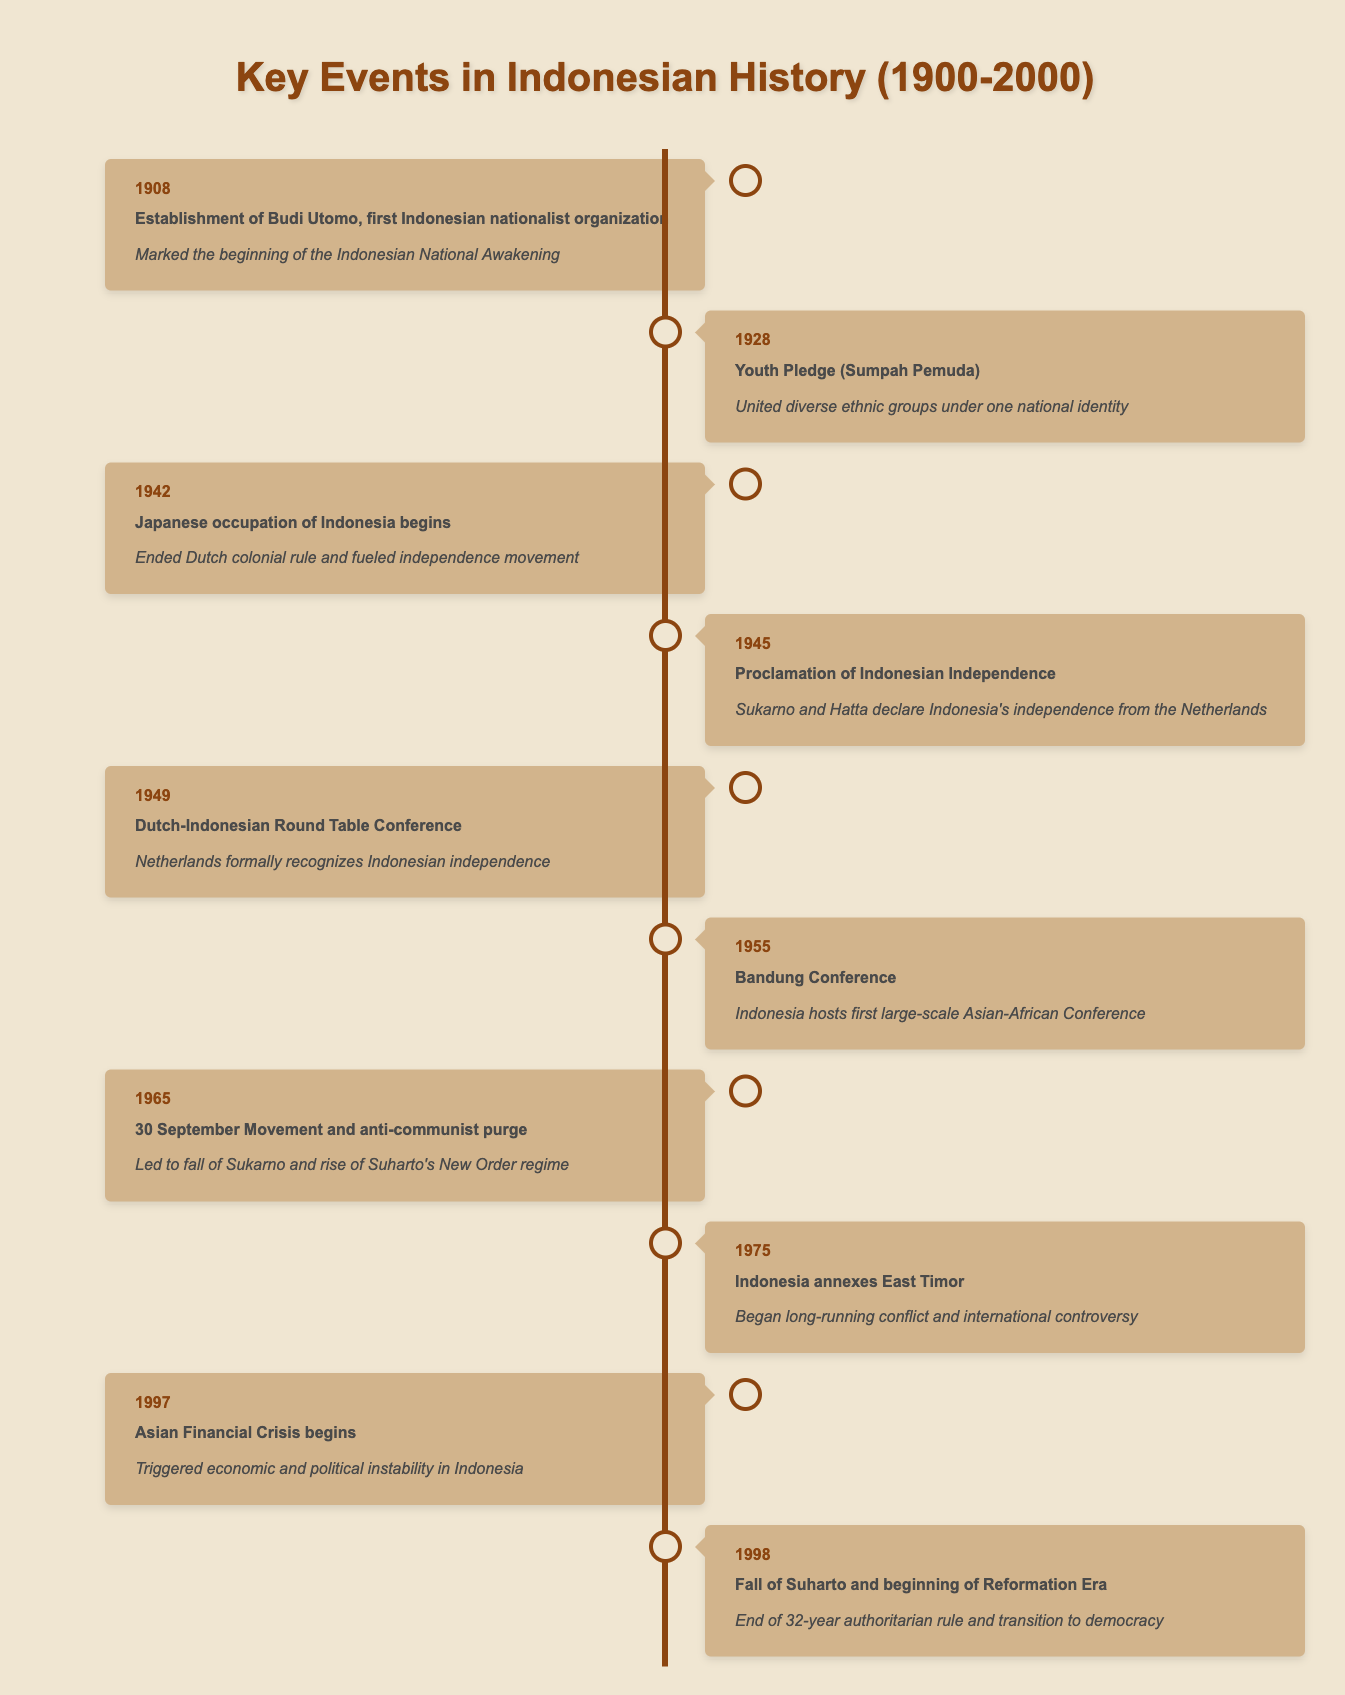What event marked the beginning of the Indonesian National Awakening? The table states that the establishment of Budi Utomo in 1908 is significant for marking the beginning of the Indonesian National Awakening.
Answer: Establishment of Budi Utomo What was the significance of the Youth Pledge in 1928? According to the table, the significance of the Youth Pledge in 1928 was that it united diverse ethnic groups under one national identity.
Answer: United diverse ethnic groups under one national identity Did the Japanese occupation lead to the end of Dutch colonial rule? The table indicates that the Japanese occupation of Indonesia beginning in 1942 ended Dutch colonial rule, thus making this statement true.
Answer: Yes How many years passed between the proclamation of Indonesian independence and the Dutch-Indonesian Round Table Conference? The proclamation of independence occurred in 1945, and the Round Table Conference was in 1949. The difference is 1949 - 1945 = 4 years.
Answer: 4 years What was the key outcome of the 30 September Movement in 1965? The table notes that the 30 September Movement led to the fall of Sukarno and the rise of Suharto's New Order regime, highlighting a significant shift in Indonesia's political landscape.
Answer: Fall of Sukarno and rise of Suharto's New Order regime How many significant events mentioned in the table occurred after 1970? The table includes significant events in 1975, 1997, and 1998 after 1970, totaling three events.
Answer: 3 significant events Was there a major conference hosted by Indonesia in 1955? The table confirms that Indonesia hosted the Bandung Conference in 1955, making this statement true.
Answer: Yes What were the results of the Asian Financial Crisis that began in 1997? The table states that the Asian Financial Crisis triggered economic and political instability in Indonesia, indicating severe effects on the country's stability.
Answer: Economic and political instability 